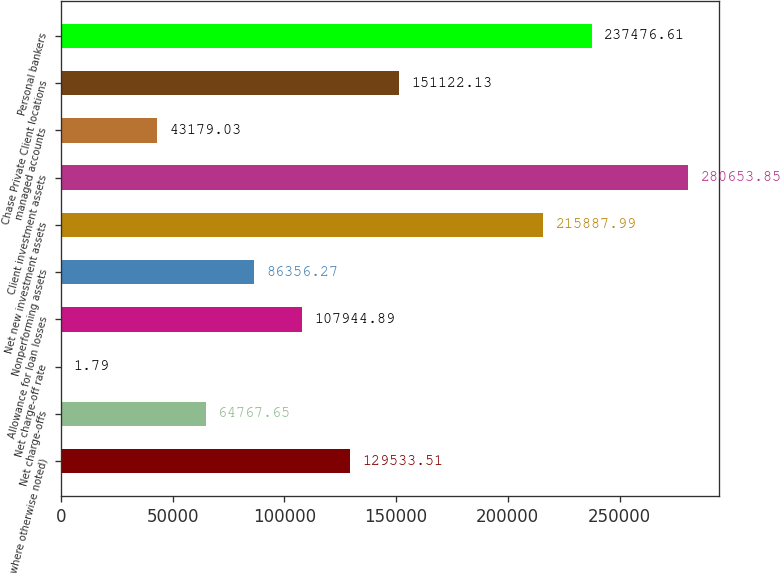Convert chart to OTSL. <chart><loc_0><loc_0><loc_500><loc_500><bar_chart><fcel>where otherwise noted)<fcel>Net charge-offs<fcel>Net charge-off rate<fcel>Allowance for loan losses<fcel>Nonperforming assets<fcel>Net new investment assets<fcel>Client investment assets<fcel>managed accounts<fcel>Chase Private Client locations<fcel>Personal bankers<nl><fcel>129534<fcel>64767.7<fcel>1.79<fcel>107945<fcel>86356.3<fcel>215888<fcel>280654<fcel>43179<fcel>151122<fcel>237477<nl></chart> 